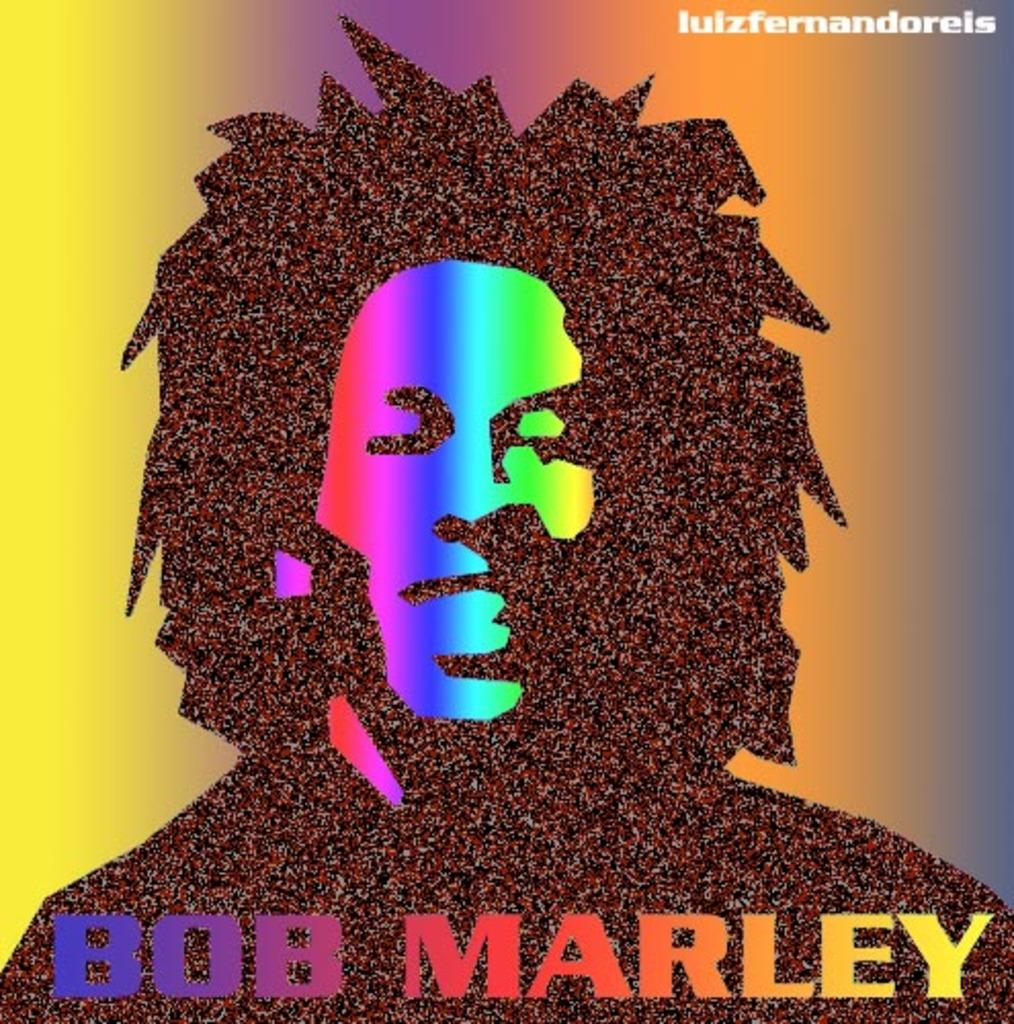<image>
Summarize the visual content of the image. A very colorful and almosy blick light looking Bob Marley poster. 